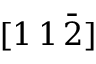<formula> <loc_0><loc_0><loc_500><loc_500>[ 1 \, 1 \, \bar { 2 } ]</formula> 